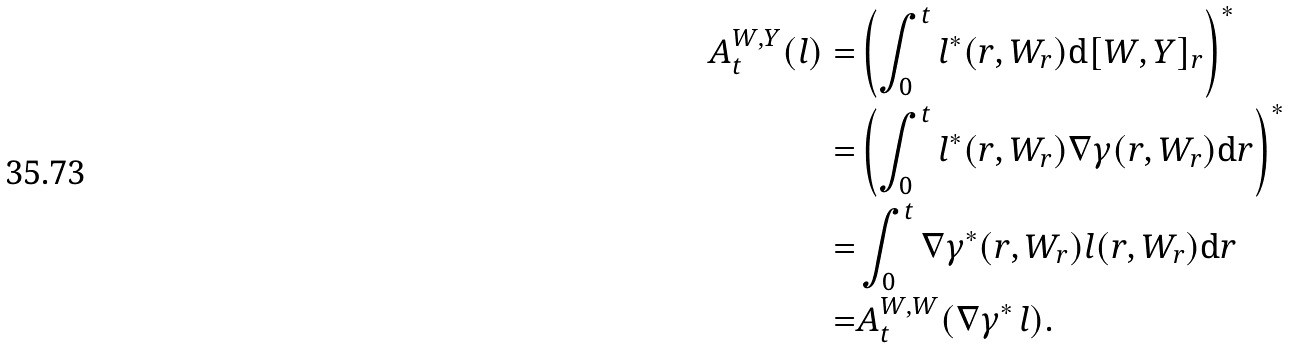<formula> <loc_0><loc_0><loc_500><loc_500>A _ { t } ^ { W , Y } ( l ) = & \left ( \int _ { 0 } ^ { t } l ^ { * } ( r , W _ { r } ) \mathrm d [ W , Y ] _ { r } \right ) ^ { * } \\ = & \left ( \int _ { 0 } ^ { t } l ^ { * } ( r , W _ { r } ) \nabla \gamma ( r , W _ { r } ) \mathrm d r \right ) ^ { * } \\ = & \int _ { 0 } ^ { t } \nabla \gamma ^ { * } ( r , W _ { r } ) l ( r , W _ { r } ) \mathrm d r \\ = & A _ { t } ^ { W , W } ( \nabla \gamma ^ { * } \, l ) .</formula> 